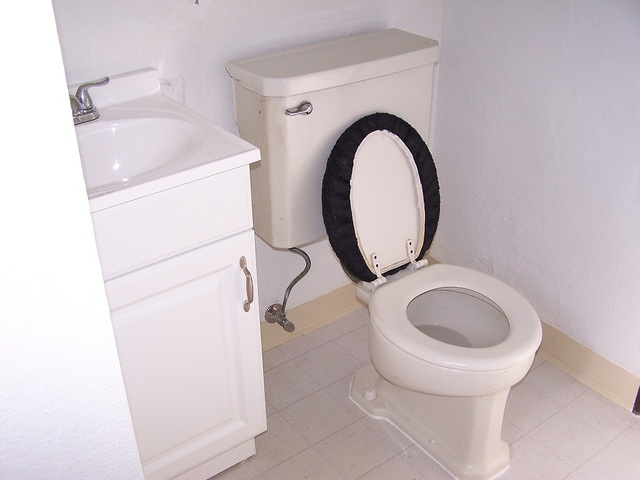Describe the objects in this image and their specific colors. I can see toilet in white, darkgray, lightgray, and black tones and sink in white, lightgray, and darkgray tones in this image. 